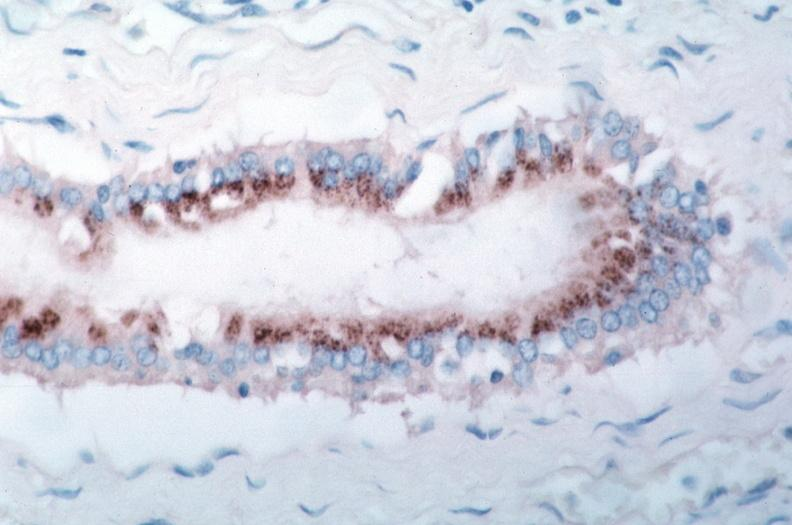s macerated stillborn spotted fever, immunoperoxidase staining vessels for rickettsia rickettsii?
Answer the question using a single word or phrase. No 